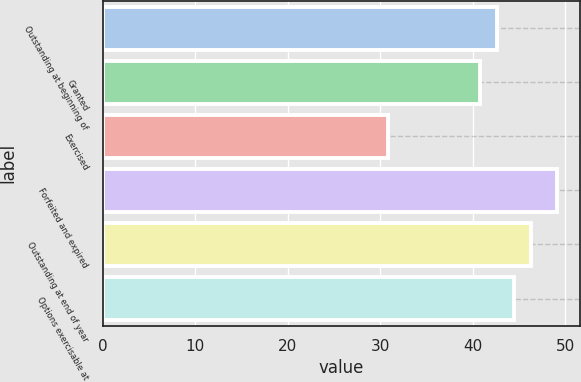<chart> <loc_0><loc_0><loc_500><loc_500><bar_chart><fcel>Outstanding at beginning of<fcel>Granted<fcel>Exercised<fcel>Forfeited and expired<fcel>Outstanding at end of year<fcel>Options exercisable at<nl><fcel>42.6<fcel>40.77<fcel>30.88<fcel>49.17<fcel>46.26<fcel>44.43<nl></chart> 